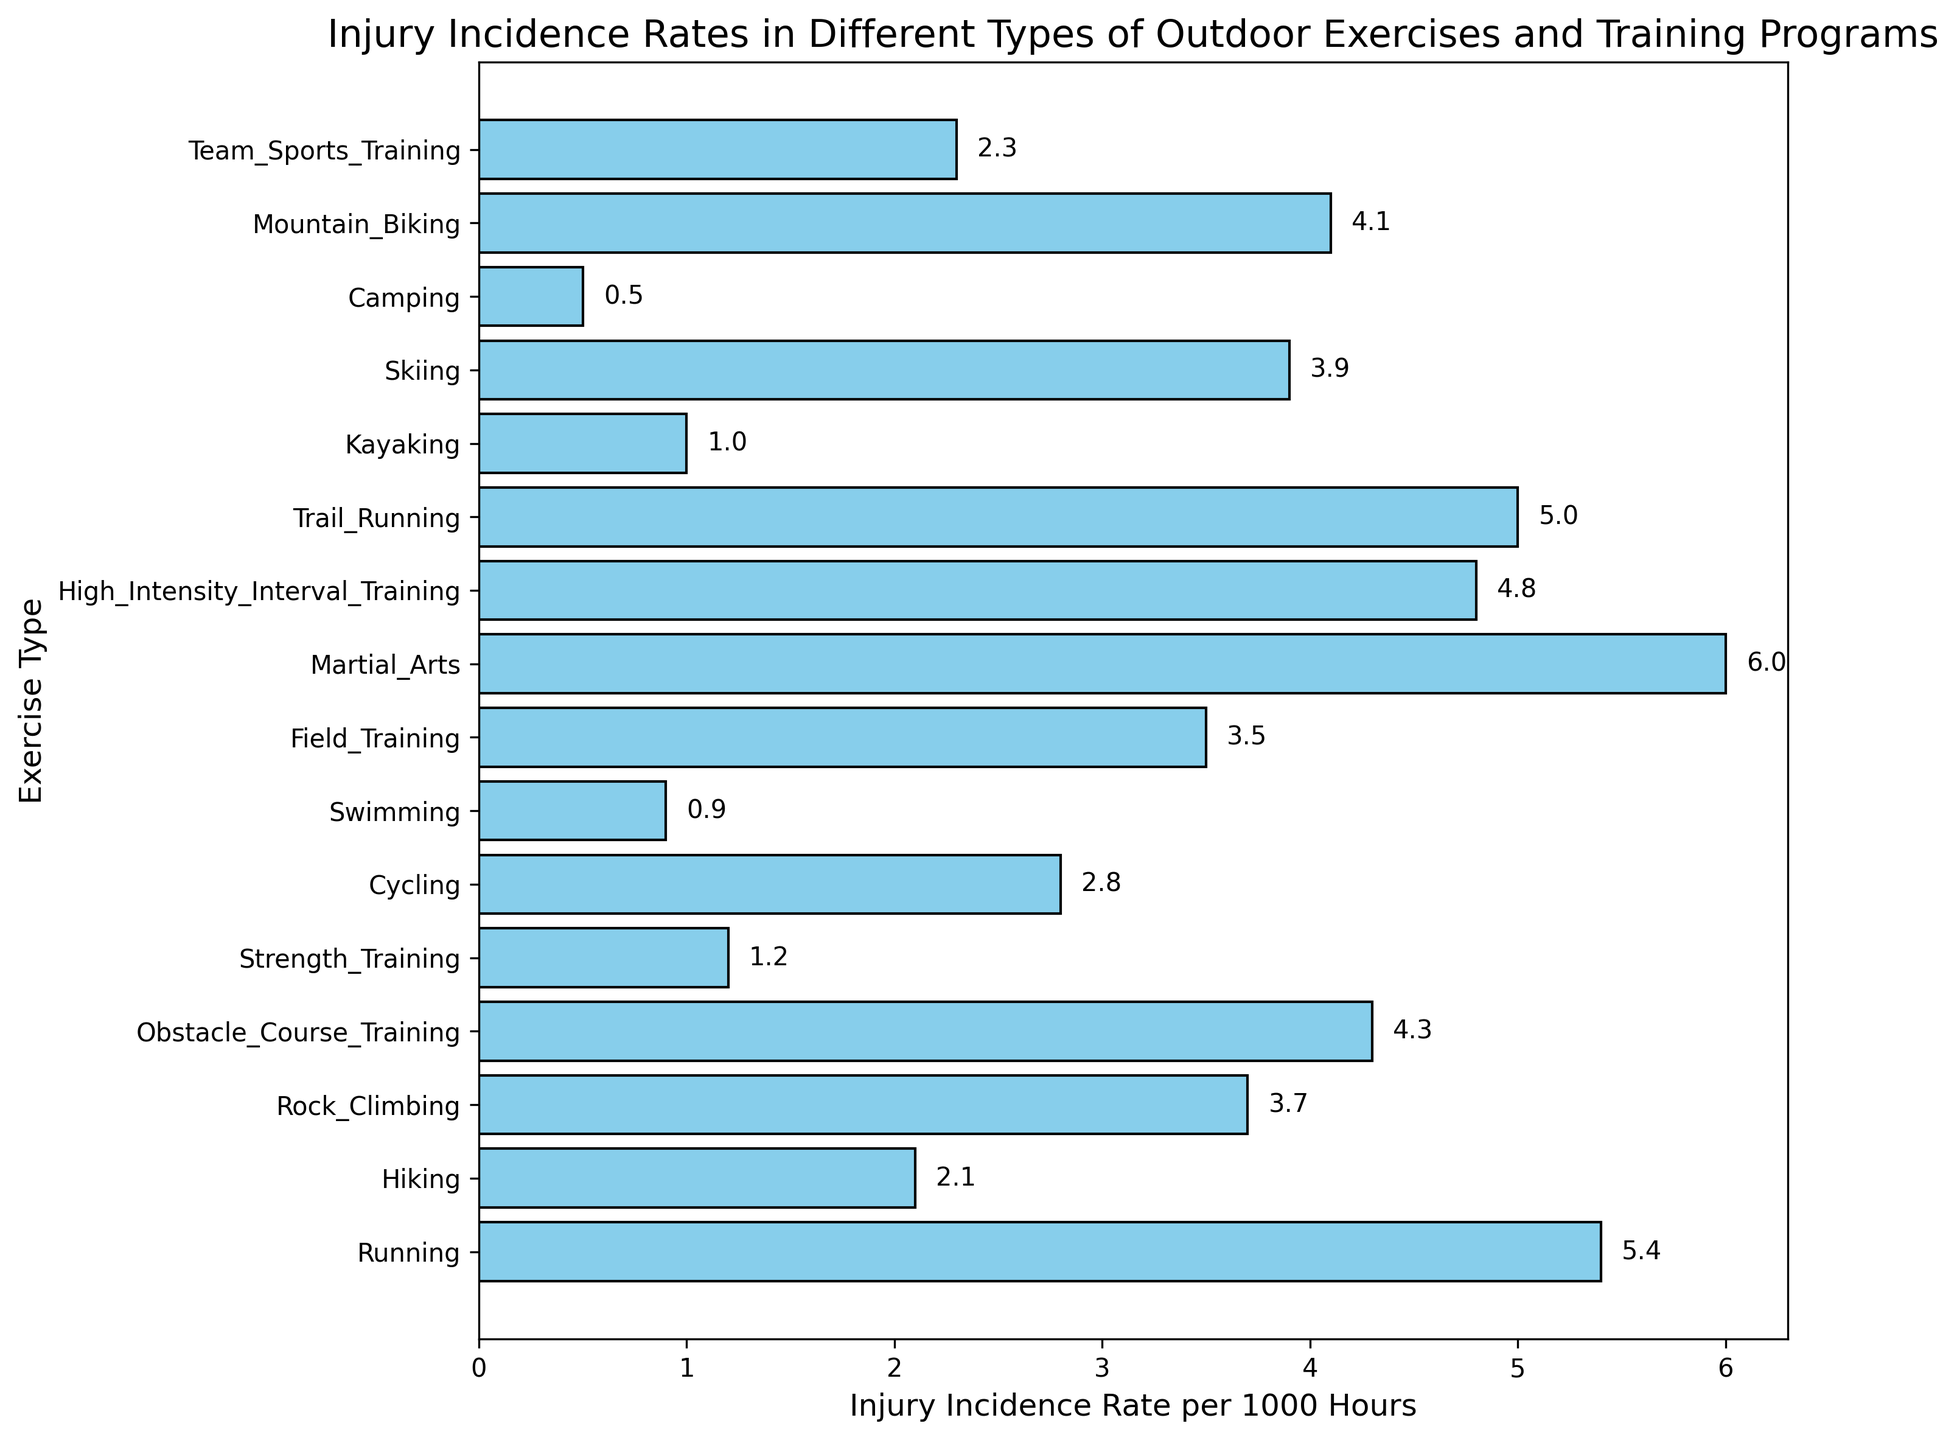Which exercise type has the highest injury incidence rate? The bar chart shows different exercises with their corresponding injury rates. By identifying the longest bar, we see Martial Arts has the highest rate.
Answer: Martial Arts Which exercise type has the lowest injury incidence rate? By identifying the shortest bar in the chart, we see Camping has the lowest rate.
Answer: Camping Which two exercise types have the smallest difference in their injury incidence rates? Comparing the lengths of the bars, we see that Kayaking (1.0) and Swimming (0.9) have rates differing by 0.1, which is the smallest difference.
Answer: Kayaking and Swimming What is the average injury incidence rate of exercises with rates above 4.0? Sum the rates of Martial Arts (6.0), High-Intensity Interval Training (4.8), Trail Running (5.0), Running (5.4), and Obstacle Course Training (4.3), then divide by the number of these exercises: (6.0 + 4.8 + 5.0 + 5.4 + 4.3) / 5 = 25.5 / 5 = 5.1
Answer: 5.1 How much higher is the injury incidence rate of Martial Arts compared to Strength Training? Subtract Strength Training’s rate (1.2) from Martial Arts’ rate (6.0): 6.0 - 1.2 = 4.8
Answer: 4.8 Which exercises have an incidence rate between 2.0 and 3.0? Identify the bars representing rates between 2.0 and 3.0: Hiking (2.1), Cycling (2.8), and Team Sports Training (2.3).
Answer: Hiking, Cycling, and Team Sports Training How many exercises have an injury incidence rate lower than 1.0? Identify the bars representing rates lower than 1.0: Swimming (0.9) and Camping (0.5).
Answer: 2 What is the total sum of injury incidence rates for Field Training, Skiing, and Cycling? Add the rates of Field Training (3.5), Skiing (3.9), and Cycling (2.8): 3.5 + 3.9 + 2.8 = 10.2
Answer: 10.2 Which exercise type has an injury incidence rate exactly double that of Kayaking? Kayaking has an incidence rate of 1.0, so double that rate is 2.0. The exercise type closest to 2.0 is Hiking with a rate of 2.1, which is not exactly double. Therefore, none exactly double.
Answer: None Which exercise types have their incidence rates above 4.0? Identify the bars representing rates above 4.0: Running (5.4), Obstacle Course Training (4.3), High-Intensity Interval Training (4.8), Trail Running (5.0), and Martial Arts (6.0).
Answer: Running, Obstacle Course Training, High-Intensity Interval Training, Trail Running, and Martial Arts 